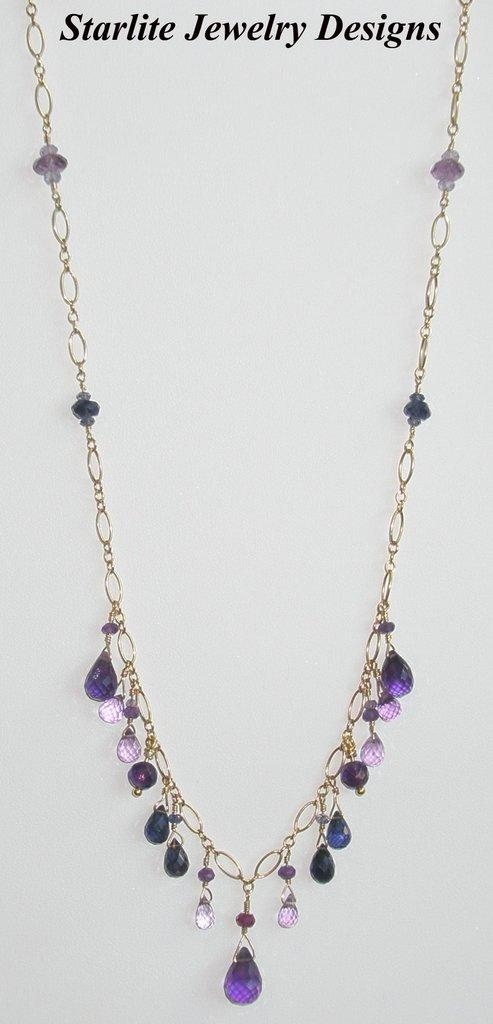What is the main subject of the picture? The main subject of the picture is a necklace. What color are the stones on the necklace? The stones on the necklace have a violet color. Is there any text present in the picture? Yes, there is some text at the top of the picture. What type of yarn is used to make the lettuce in the picture? There is no yarn or lettuce present in the picture; it features a necklace with violet color stones and some text at the top. What kind of agreement is being discussed in the picture? There is no discussion or agreement present in the picture; it only contains a necklace and some text. 